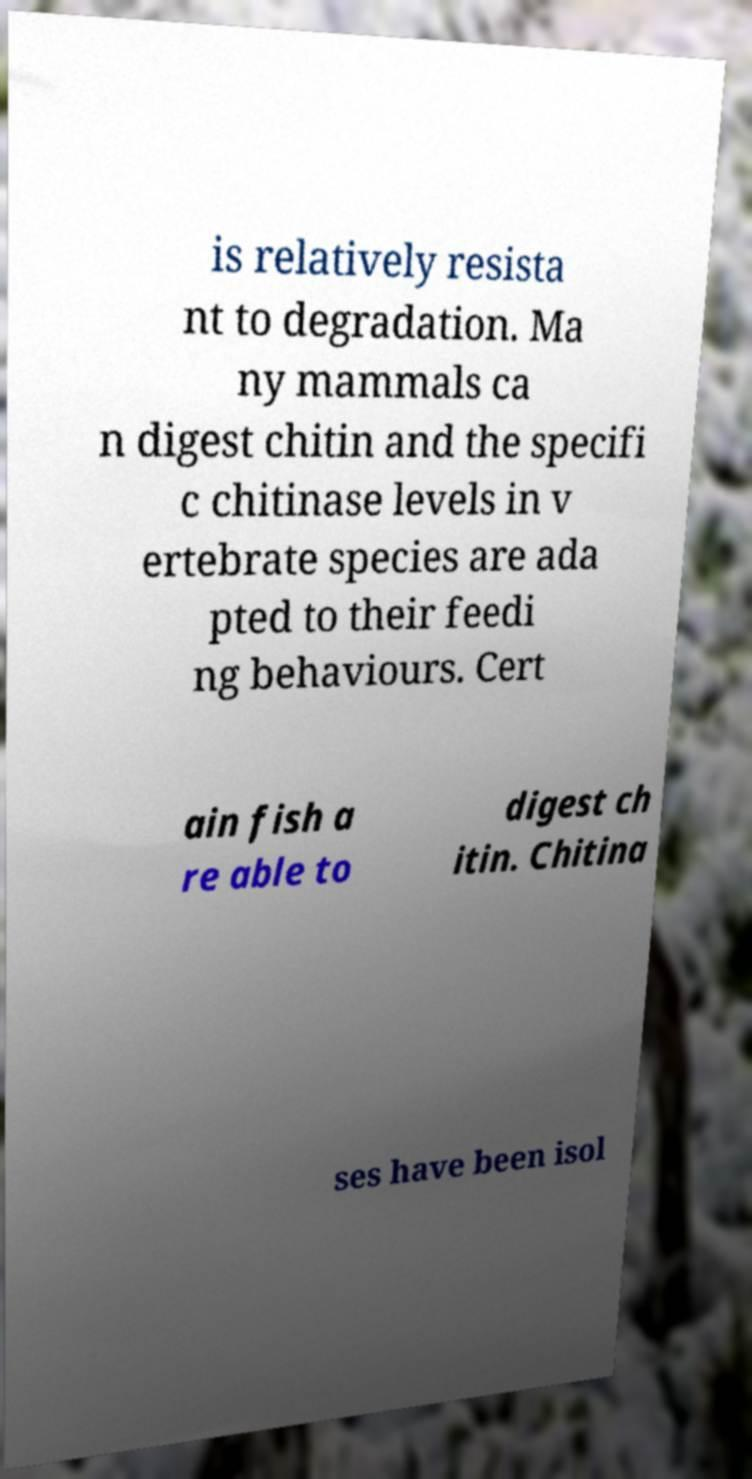Please identify and transcribe the text found in this image. is relatively resista nt to degradation. Ma ny mammals ca n digest chitin and the specifi c chitinase levels in v ertebrate species are ada pted to their feedi ng behaviours. Cert ain fish a re able to digest ch itin. Chitina ses have been isol 